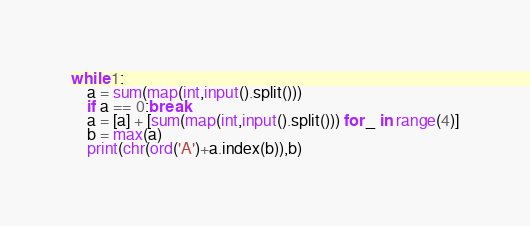<code> <loc_0><loc_0><loc_500><loc_500><_Python_>while 1:
    a = sum(map(int,input().split()))
    if a == 0:break
    a = [a] + [sum(map(int,input().split())) for _ in range(4)]
    b = max(a)
    print(chr(ord('A')+a.index(b)),b)
</code> 